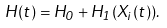<formula> <loc_0><loc_0><loc_500><loc_500>H ( t ) = H _ { 0 } + H _ { 1 } ( X _ { i } ( t ) ) .</formula> 